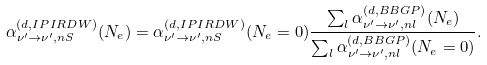Convert formula to latex. <formula><loc_0><loc_0><loc_500><loc_500>\alpha ^ { ( d , I P I R D W ) } _ { \nu ^ { \prime } \rightarrow \nu ^ { \prime } , n S } ( N _ { e } ) = \alpha ^ { ( d , I P I R D W ) } _ { \nu ^ { \prime } \rightarrow \nu ^ { \prime } , n S } ( N _ { e } = 0 ) \frac { \sum _ { l } \alpha ^ { ( d , B B G P ) } _ { \nu ^ { \prime } \rightarrow \nu ^ { \prime } , n l } ( N _ { e } ) } { \sum _ { l } \alpha ^ { ( d , B B G P ) } _ { \nu ^ { \prime } \rightarrow \nu ^ { \prime } , n l } ( N _ { e } = 0 ) } .</formula> 